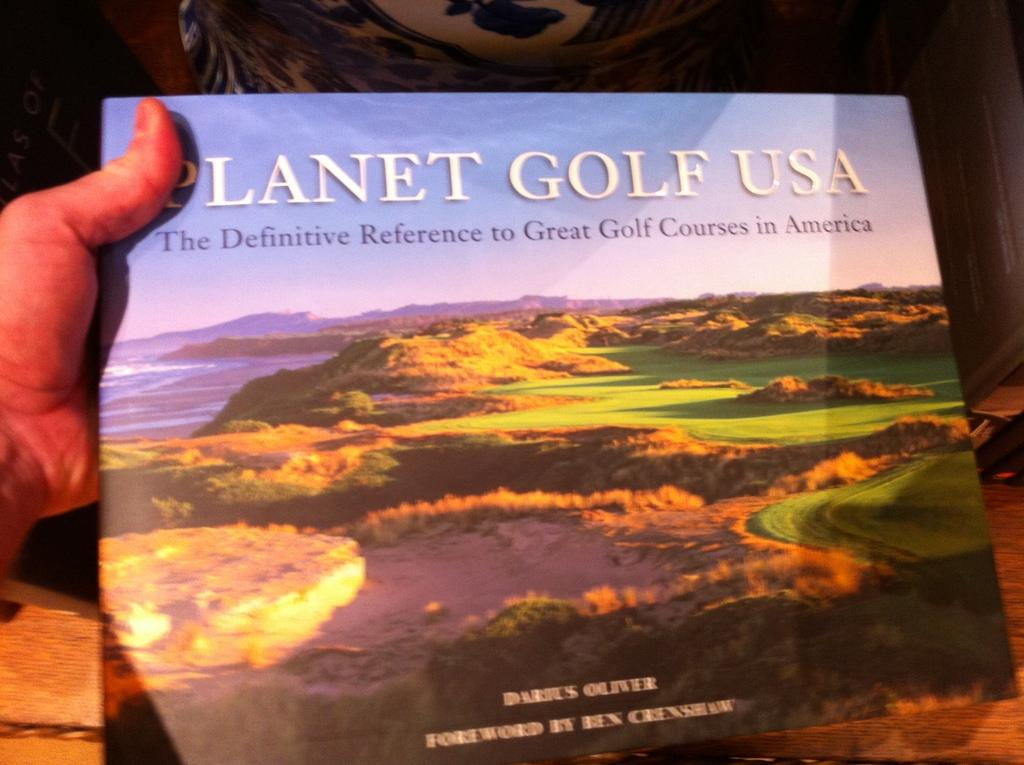<image>
Relay a brief, clear account of the picture shown. A hand holds a book about gold courses in America. 